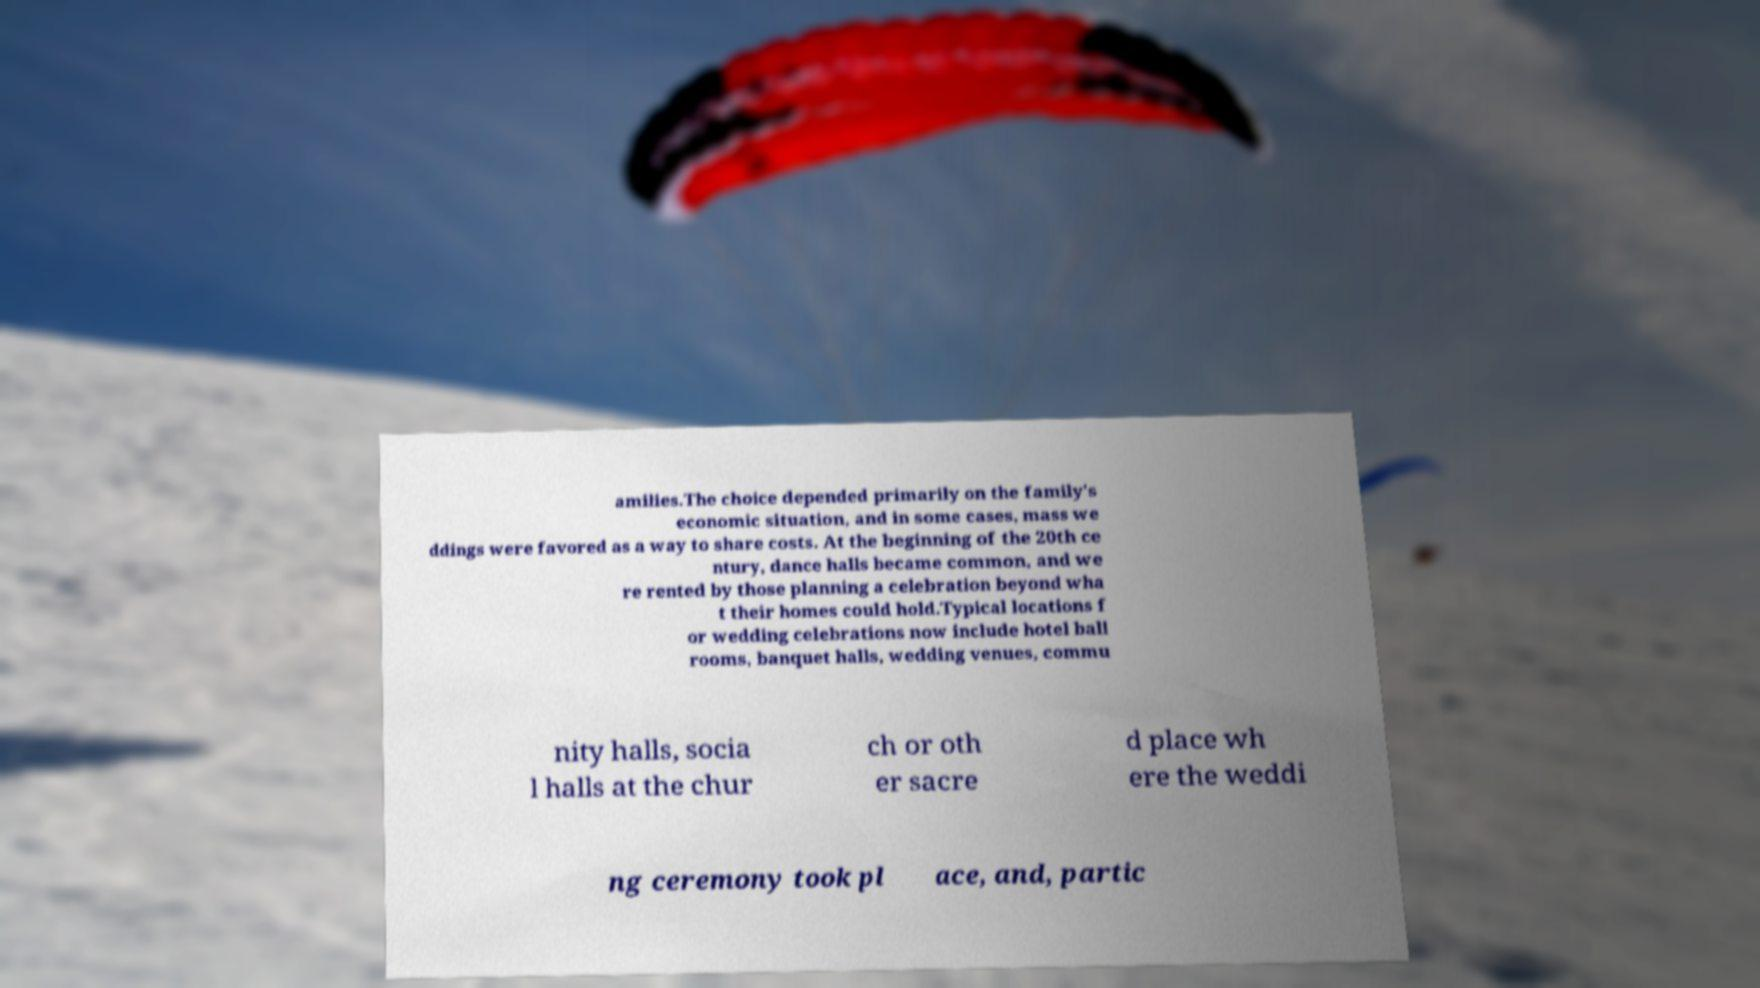What messages or text are displayed in this image? I need them in a readable, typed format. amilies.The choice depended primarily on the family's economic situation, and in some cases, mass we ddings were favored as a way to share costs. At the beginning of the 20th ce ntury, dance halls became common, and we re rented by those planning a celebration beyond wha t their homes could hold.Typical locations f or wedding celebrations now include hotel ball rooms, banquet halls, wedding venues, commu nity halls, socia l halls at the chur ch or oth er sacre d place wh ere the weddi ng ceremony took pl ace, and, partic 